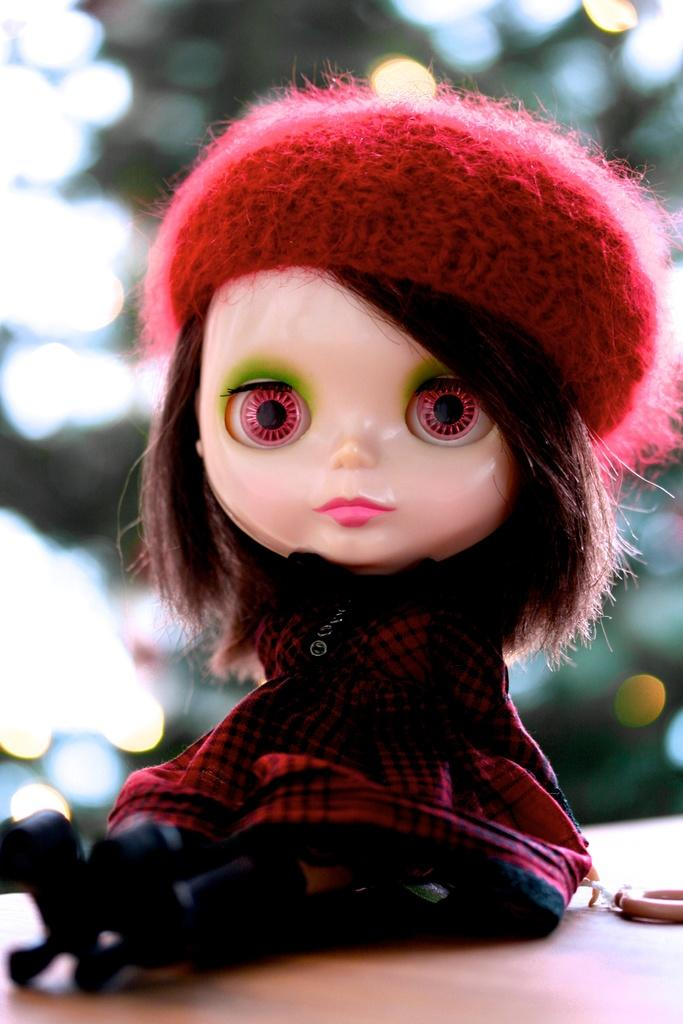What type of object is in the image? There is a toy in the image. What is the toy wearing? The toy is wearing a red dress and a red hat. Where is the toy located? The toy is placed on a table. How many bells are attached to the toy in the image? There are no bells present on the toy in the image. Is the toy sitting on a chair in the image? The image does not show the toy sitting on a chair; it is placed on a table. 